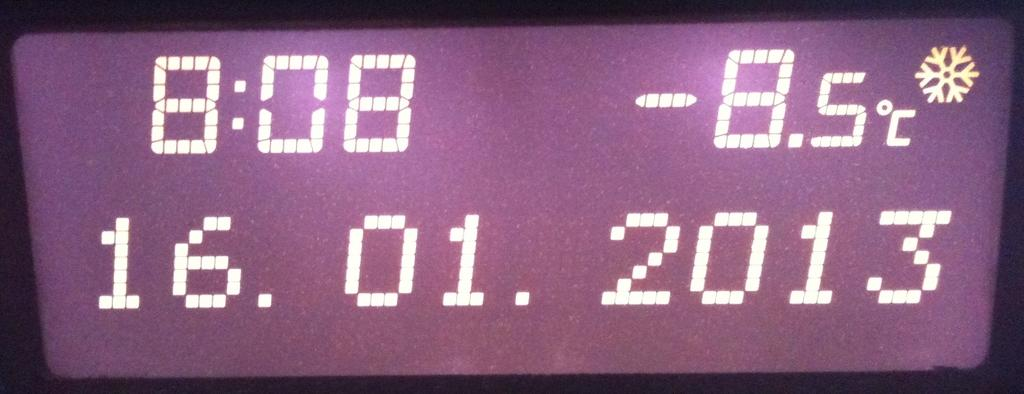Provide a one-sentence caption for the provided image. Temperature reading that reads at 8:08, the temperature is at -8.5 degrees celcius. 